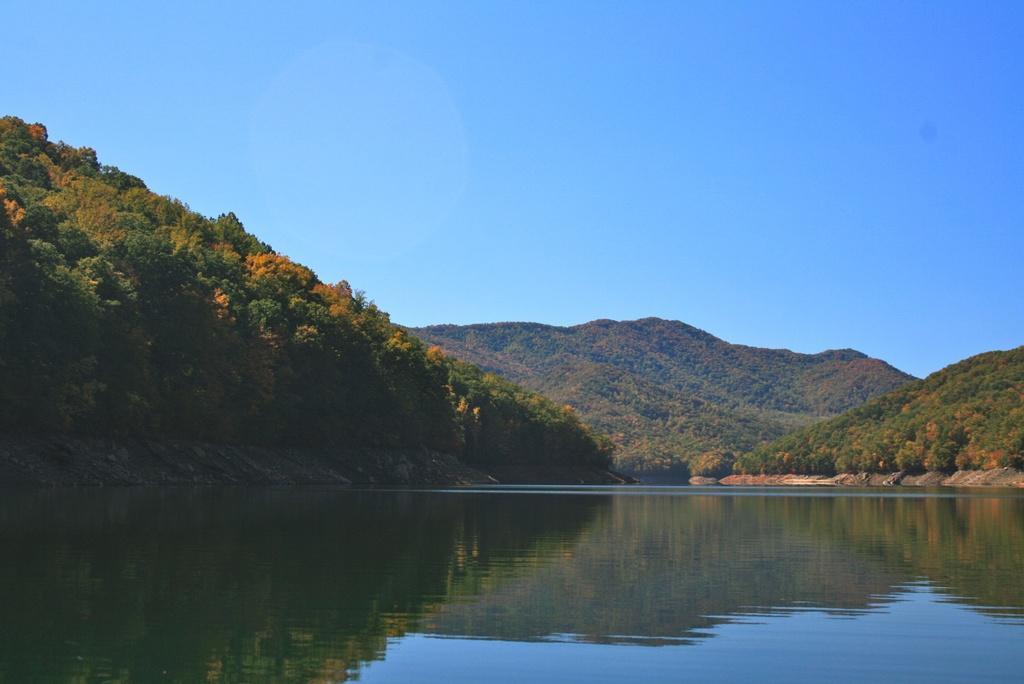Please provide a concise description of this image. In this picture we can see water at the bottom, in the background there are some trees, we can see the sky at the top of the picture. 